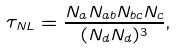Convert formula to latex. <formula><loc_0><loc_0><loc_500><loc_500>\tau _ { N L } = \frac { N _ { a } N _ { a b } N _ { b c } N _ { c } } { ( N _ { d } N _ { d } ) ^ { 3 } } ,</formula> 